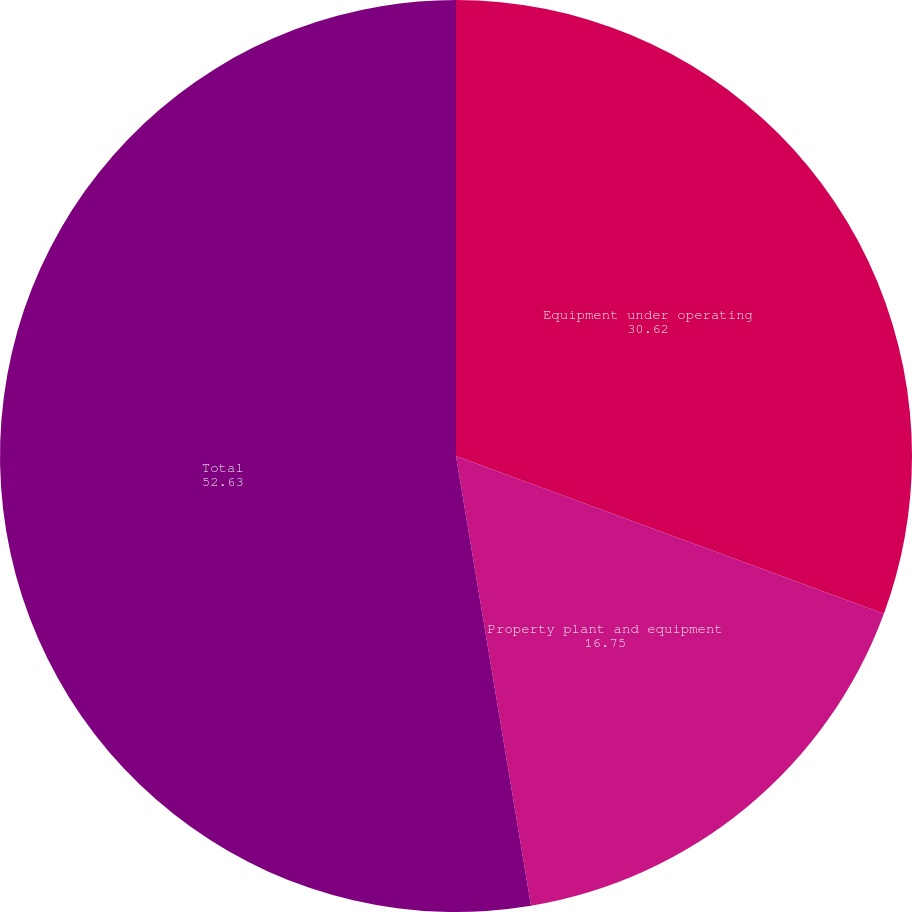<chart> <loc_0><loc_0><loc_500><loc_500><pie_chart><fcel>Equipment under operating<fcel>Property plant and equipment<fcel>Total<nl><fcel>30.62%<fcel>16.75%<fcel>52.63%<nl></chart> 